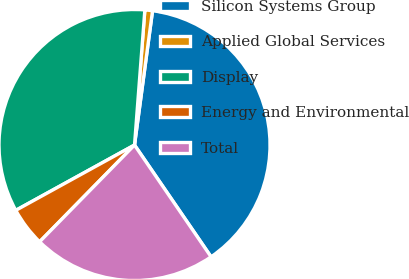Convert chart. <chart><loc_0><loc_0><loc_500><loc_500><pie_chart><fcel>Silicon Systems Group<fcel>Applied Global Services<fcel>Display<fcel>Energy and Environmental<fcel>Total<nl><fcel>38.32%<fcel>0.91%<fcel>34.22%<fcel>4.65%<fcel>21.9%<nl></chart> 